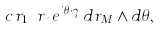Convert formula to latex. <formula><loc_0><loc_0><loc_500><loc_500>c \, r _ { 1 } \cdots r _ { n } e ^ { i \theta \cdot \gamma } \, d r _ { M } \wedge d \theta ,</formula> 